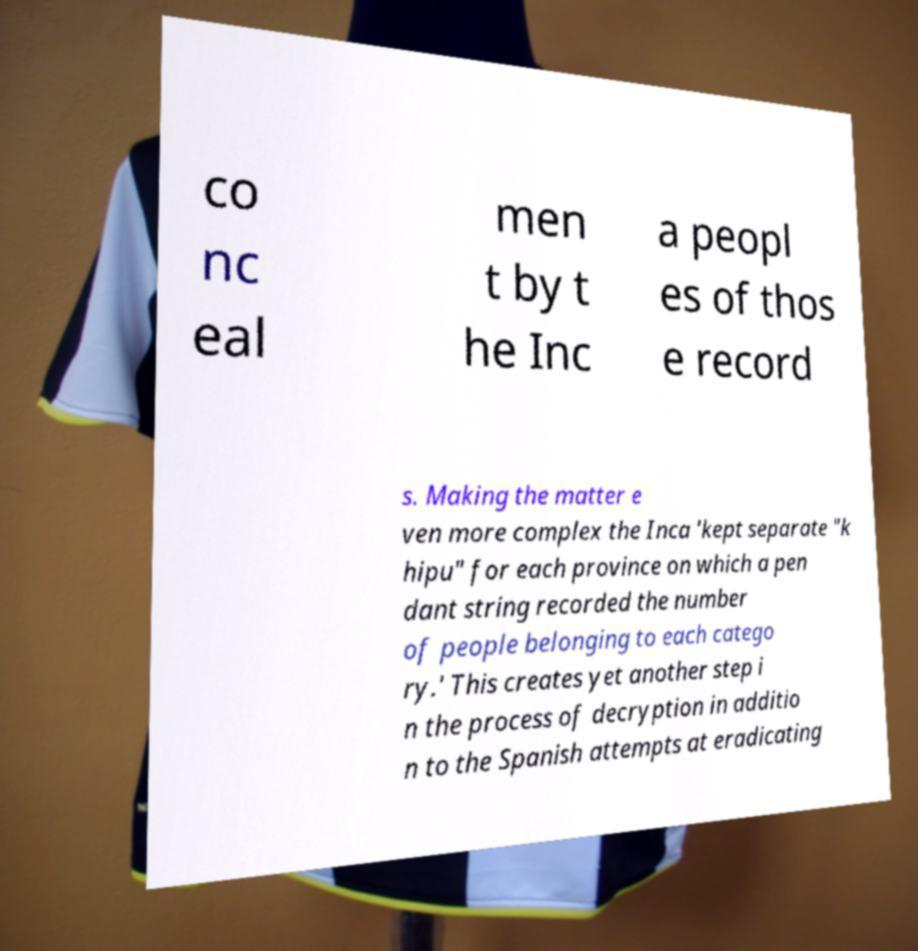There's text embedded in this image that I need extracted. Can you transcribe it verbatim? co nc eal men t by t he Inc a peopl es of thos e record s. Making the matter e ven more complex the Inca 'kept separate "k hipu" for each province on which a pen dant string recorded the number of people belonging to each catego ry.' This creates yet another step i n the process of decryption in additio n to the Spanish attempts at eradicating 